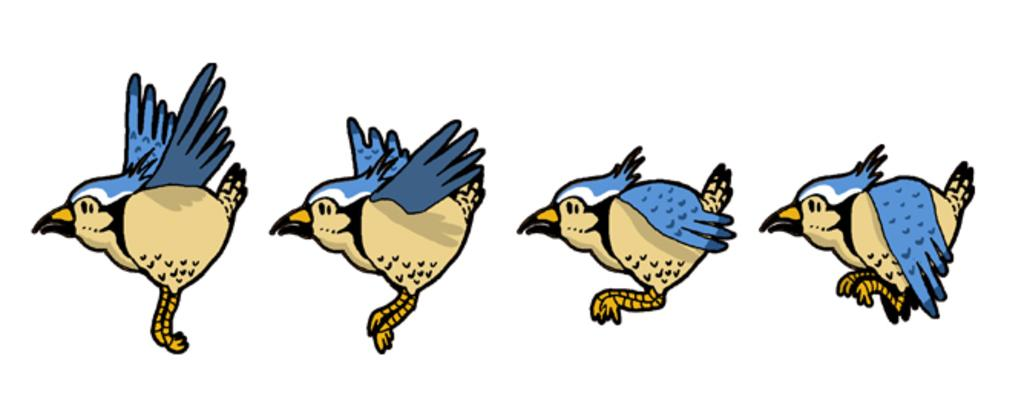What is depicted in the image? There is a sketch of birds in the image. What type of hammer is being used by the birds in the image? There is no hammer present in the image; it features a sketch of birds. What direction is the train traveling in the image? There is no train present in the image; it features a sketch of birds. 